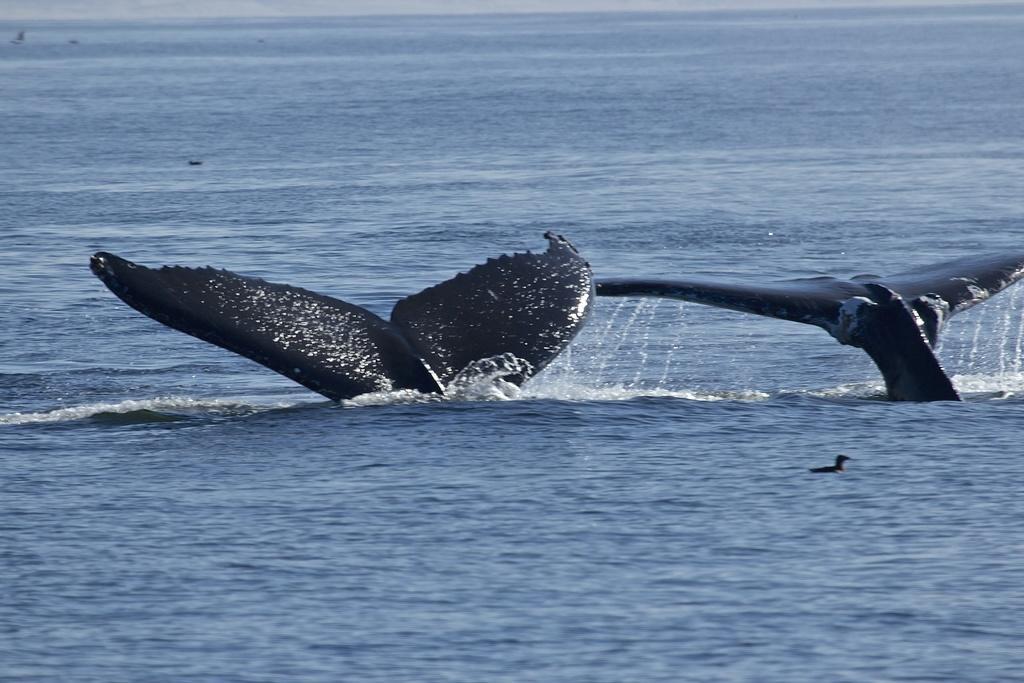Please provide a concise description of this image. In this picture we can see two dolphins are in the water and a bird. 